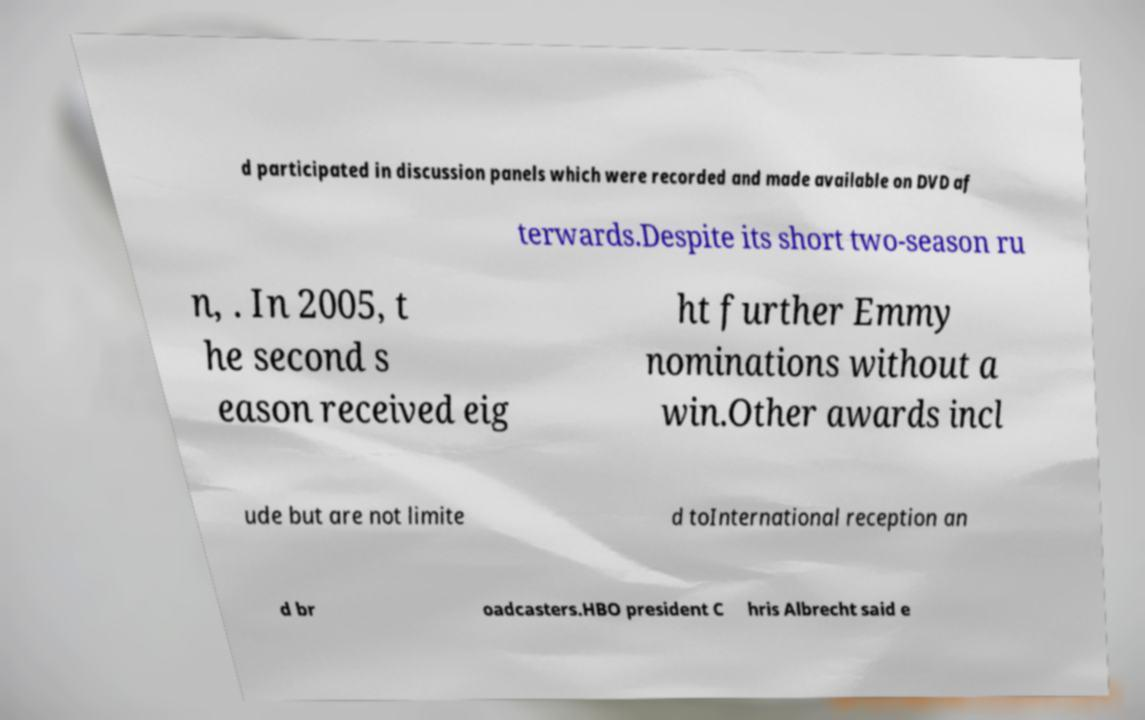Could you assist in decoding the text presented in this image and type it out clearly? d participated in discussion panels which were recorded and made available on DVD af terwards.Despite its short two-season ru n, . In 2005, t he second s eason received eig ht further Emmy nominations without a win.Other awards incl ude but are not limite d toInternational reception an d br oadcasters.HBO president C hris Albrecht said e 